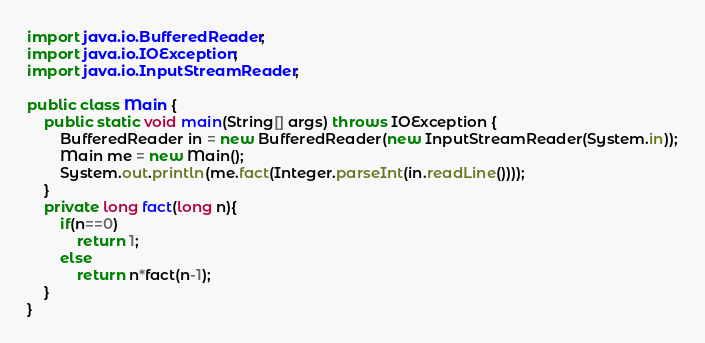<code> <loc_0><loc_0><loc_500><loc_500><_Java_>import java.io.BufferedReader;
import java.io.IOException;
import java.io.InputStreamReader;

public class Main {
	public static void main(String[] args) throws IOException {
		BufferedReader in = new BufferedReader(new InputStreamReader(System.in));
		Main me = new Main();
		System.out.println(me.fact(Integer.parseInt(in.readLine())));
	}
	private long fact(long n){
		if(n==0)
			return 1;
		else
			return n*fact(n-1);
	}
}</code> 